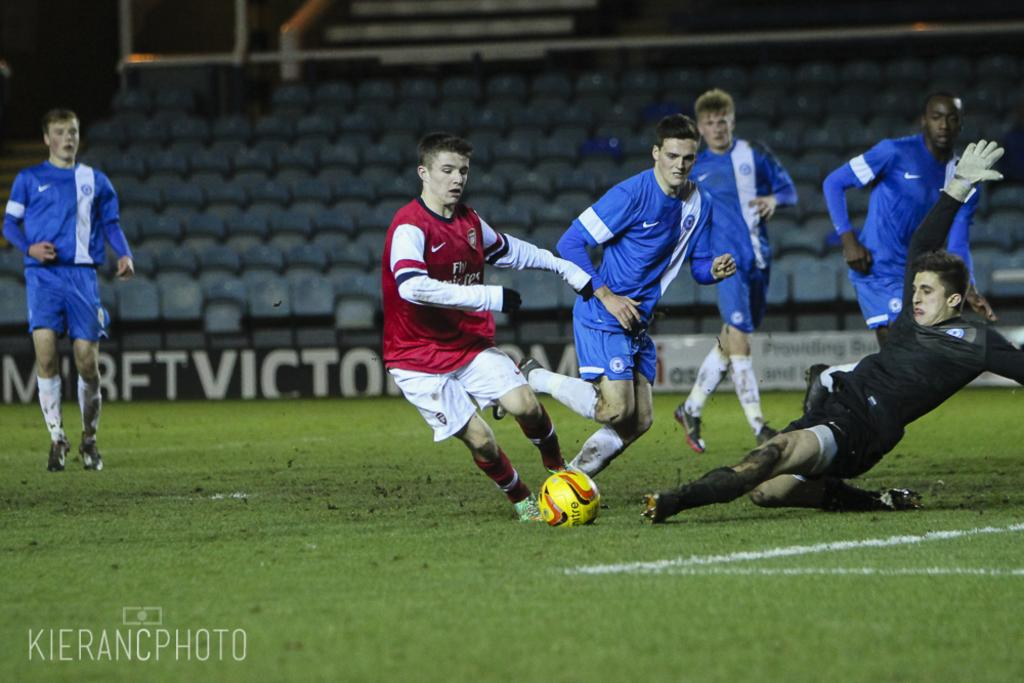What activity are the people in the image engaged in? The people in the image are playing football. What object is central to their activity? There is a football in the image. Where does the image appear to be set? The setting appears to be a stadium. What type of seating can be seen in the image? There are chairs visible at the back side of the image. What type of car is parked near the football field in the image? There is no car present in the image; it only shows a group of people playing football in a stadium setting. 